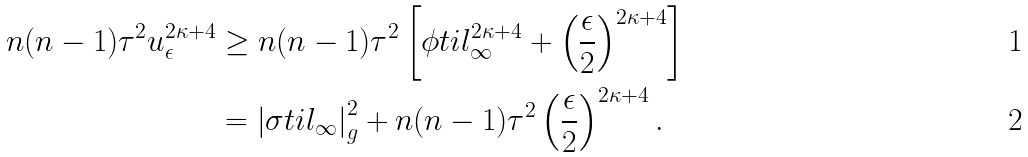<formula> <loc_0><loc_0><loc_500><loc_500>n ( n - 1 ) \tau ^ { 2 } u _ { \epsilon } ^ { 2 \kappa + 4 } & \geq n ( n - 1 ) \tau ^ { 2 } \left [ \phi t i l _ { \infty } ^ { 2 \kappa + 4 } + \left ( \frac { \epsilon } { 2 } \right ) ^ { 2 \kappa + 4 } \right ] \\ & = \left | \sigma t i l _ { \infty } \right | _ { g } ^ { 2 } + n ( n - 1 ) \tau ^ { 2 } \left ( \frac { \epsilon } { 2 } \right ) ^ { 2 \kappa + 4 } .</formula> 